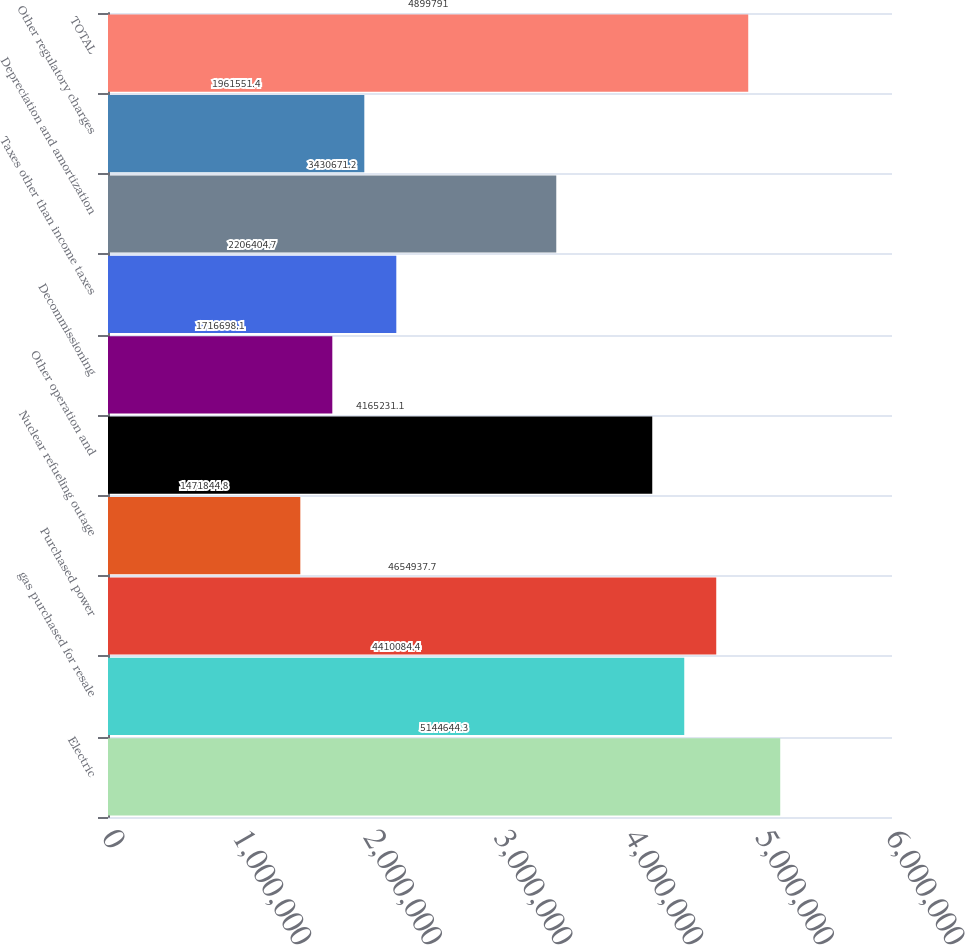Convert chart. <chart><loc_0><loc_0><loc_500><loc_500><bar_chart><fcel>Electric<fcel>gas purchased for resale<fcel>Purchased power<fcel>Nuclear refueling outage<fcel>Other operation and<fcel>Decommissioning<fcel>Taxes other than income taxes<fcel>Depreciation and amortization<fcel>Other regulatory charges<fcel>TOTAL<nl><fcel>5.14464e+06<fcel>4.41008e+06<fcel>4.65494e+06<fcel>1.47184e+06<fcel>4.16523e+06<fcel>1.7167e+06<fcel>2.2064e+06<fcel>3.43067e+06<fcel>1.96155e+06<fcel>4.89979e+06<nl></chart> 